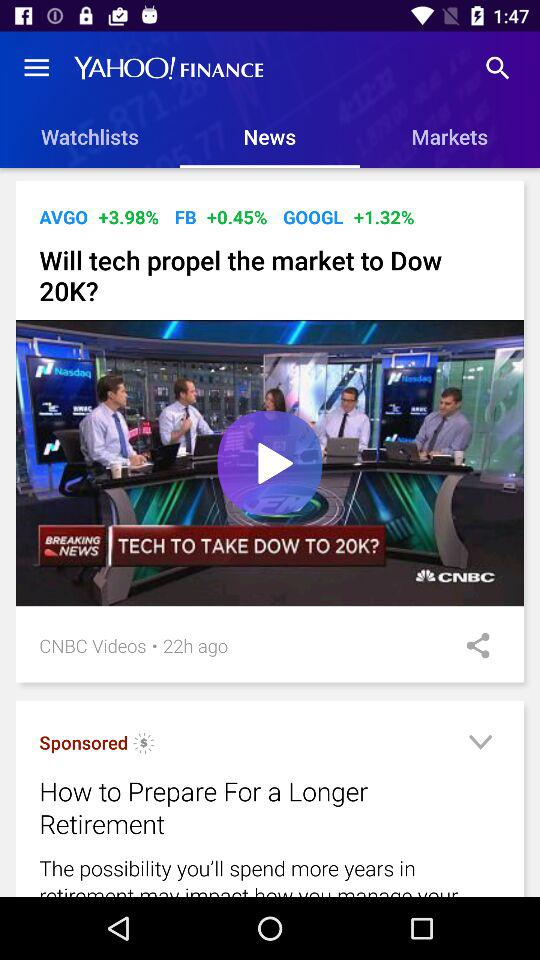What is the name of the video? The name of the video is "Will tech propel the market to Dow 20K?". 